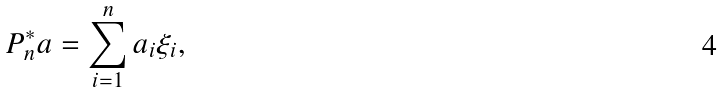Convert formula to latex. <formula><loc_0><loc_0><loc_500><loc_500>P _ { n } ^ { * } a = \sum _ { i = 1 } ^ { n } a _ { i } \xi _ { i } ,</formula> 